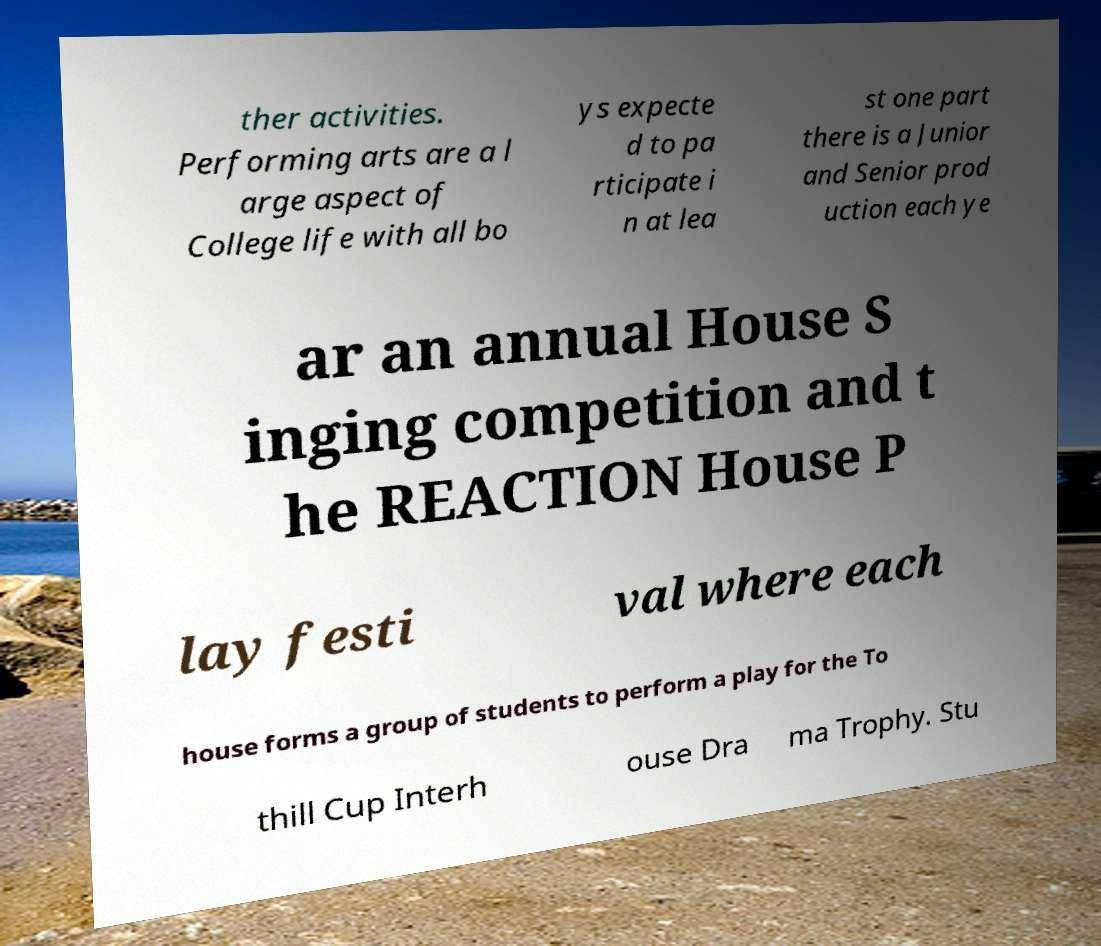Could you assist in decoding the text presented in this image and type it out clearly? ther activities. Performing arts are a l arge aspect of College life with all bo ys expecte d to pa rticipate i n at lea st one part there is a Junior and Senior prod uction each ye ar an annual House S inging competition and t he REACTION House P lay festi val where each house forms a group of students to perform a play for the To thill Cup Interh ouse Dra ma Trophy. Stu 